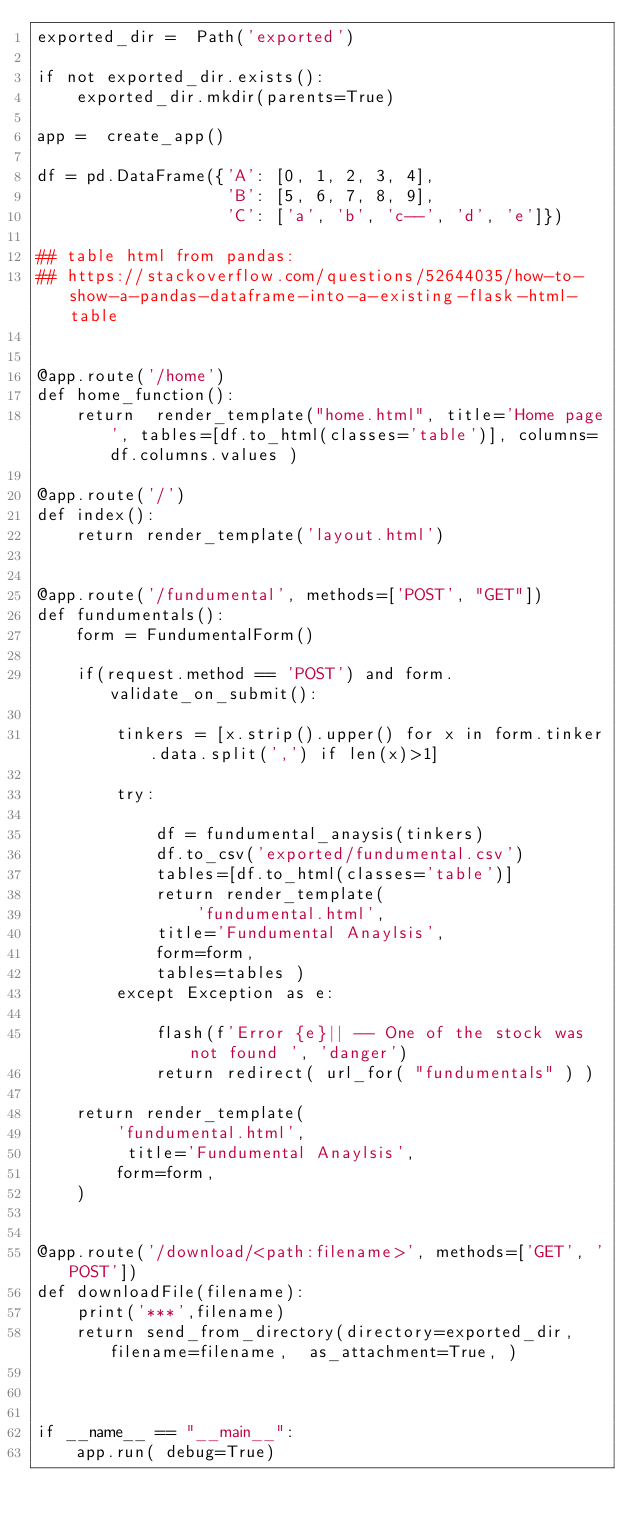<code> <loc_0><loc_0><loc_500><loc_500><_Python_>exported_dir =  Path('exported')

if not exported_dir.exists():
    exported_dir.mkdir(parents=True)

app =  create_app()

df = pd.DataFrame({'A': [0, 1, 2, 3, 4],
                   'B': [5, 6, 7, 8, 9],
                   'C': ['a', 'b', 'c--', 'd', 'e']})

## table html from pandas:
## https://stackoverflow.com/questions/52644035/how-to-show-a-pandas-dataframe-into-a-existing-flask-html-table 


@app.route('/home')
def home_function():
    return  render_template("home.html", title='Home page', tables=[df.to_html(classes='table')], columns=df.columns.values )

@app.route('/')
def index():
    return render_template('layout.html')


@app.route('/fundumental', methods=['POST', "GET"])
def fundumentals():
    form = FundumentalForm()
 
    if(request.method == 'POST') and form.validate_on_submit():
        
        tinkers = [x.strip().upper() for x in form.tinker.data.split(',') if len(x)>1]

        try: 
        
            df = fundumental_anaysis(tinkers)
            df.to_csv('exported/fundumental.csv')
            tables=[df.to_html(classes='table')]
            return render_template( 
                'fundumental.html',
            title='Fundumental Anaylsis',
            form=form,
            tables=tables )
        except Exception as e:

            flash(f'Error {e}|| -- One of the stock was not found ', 'danger')
            return redirect( url_for( "fundumentals" ) )

    return render_template(
        'fundumental.html',
         title='Fundumental Anaylsis',
        form=form,
    )


@app.route('/download/<path:filename>', methods=['GET', 'POST'])
def downloadFile(filename):
    print('***',filename)
    return send_from_directory(directory=exported_dir, filename=filename,  as_attachment=True, )



if __name__ == "__main__":
    app.run( debug=True)</code> 